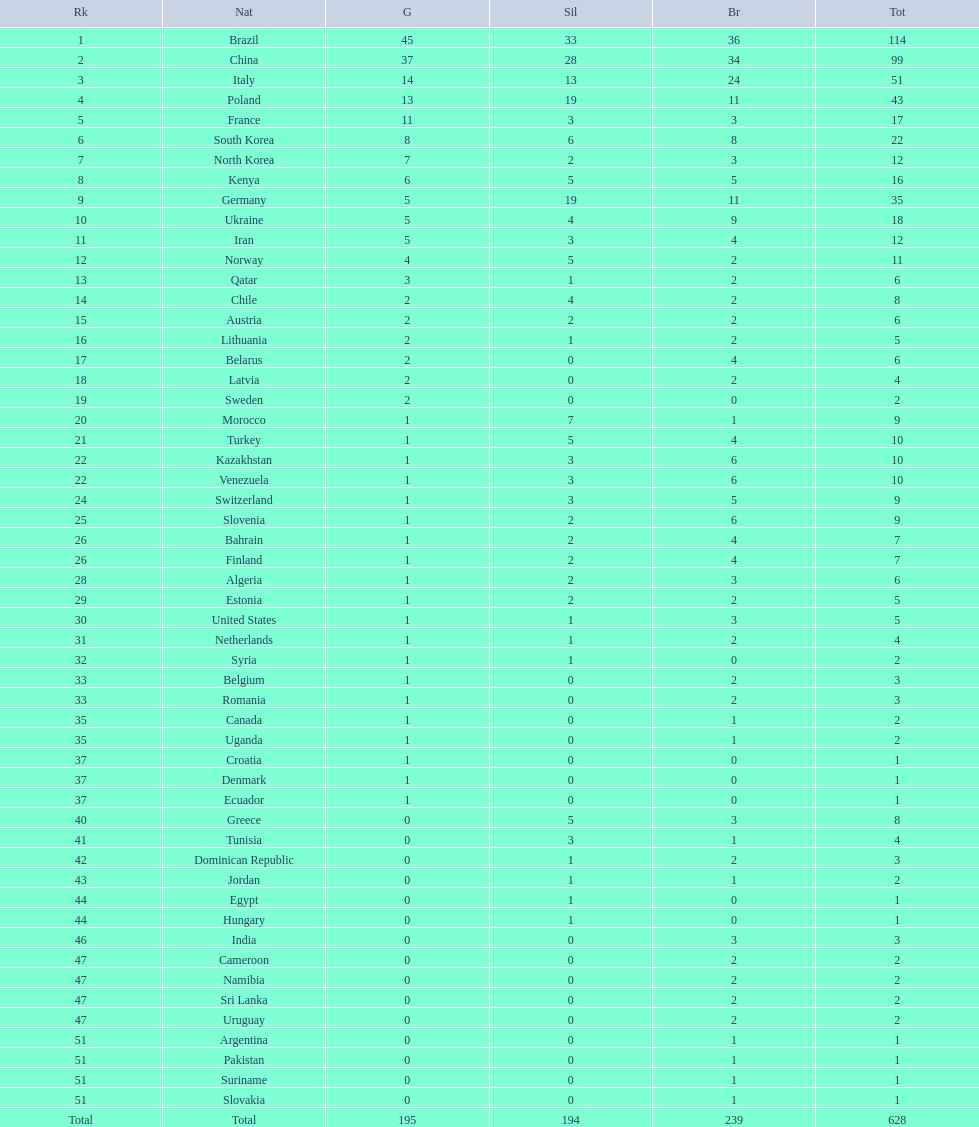Which type of medal does belarus not have? Silver. 